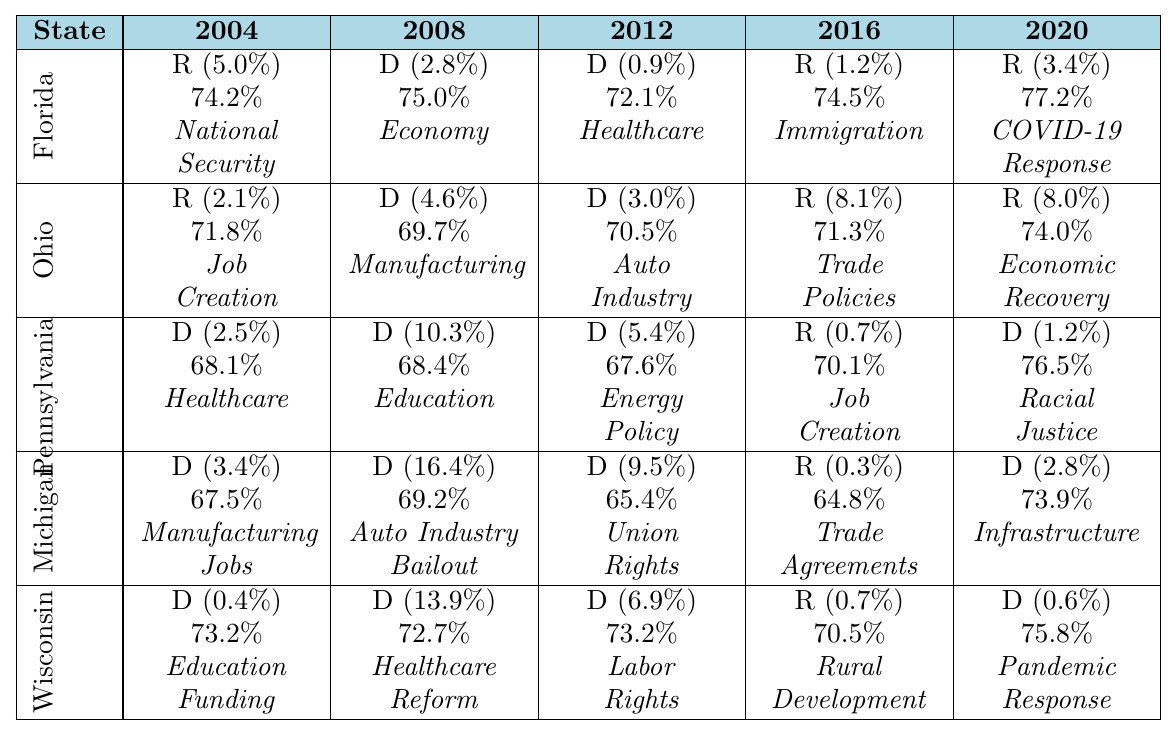What was the winner in Florida for the 2008 election? The table shows that in Florida for the 2008 election, the winner was a Democrat (D) with a margin of 2.8%.
Answer: Democrat Which state had the highest voter turnout in the 2012 election? Looking at the voter turnout for the 2012 election, Florida had a turnout of 72.1%, Ohio had 70.5%, Pennsylvania had 67.6%, Michigan had 65.4%, and Wisconsin had 73.2%. The highest voter turnout was in Wisconsin with 73.2%.
Answer: Wisconsin What was the average margin of victory for Republicans in the last three elections (2016, 2020, and 2024)? For 2016, the Republican margin in Florida was 1.2%, in Ohio it was 8.1%, in Pennsylvania it was 0.7%, in Michigan it was 0.3%, and in Wisconsin it was 0.7%. In 2020, the margins for Republicans were 3.4%, 8.0%, and none for Pennsylvania and Michigan as Democrats won. Thus, we only consider Florida, Ohio, and Wisconsin which had margins of 1.2%, 8.1%, and 0.7%, totaling 10.0%, averaging to 10.0% / 3 = 3.33%.
Answer: 3.33% Did voter turnout increase or decrease in Pennsylvania from 2012 to 2020? In Pennsylvania, the voter turnout was 67.6% in 2012 and increased to 76.5% in 2020. Since 76.5% is greater than 67.6%, it indicates a clear increase.
Answer: Increase How did the voting pattern in Michigan change from 2008 to 2016? In 2008, Democrats won with a margin of 16.4% in Michigan, while in 2016, Republicans won with a margin of only 0.3%. This shows a significant shift from Democratic to Republican dominance.
Answer: Shift to Republican Which key issue was predominant in Ohio for the 2016 election? The key issue listed for Ohio in the 2016 election was Trade Policies. This can be directly read from the respective row for the state and election.
Answer: Trade Policies Which state had a consistent Democratic majority across all five elections? Examining the table, Pennsylvania shows a Democratic majority in 2004, 2008, 2012, and 2020, only showing a Republican win in 2016. Thus, it does not hold a consistent majority. No state had a consistent majority as all had at least one Republican win.
Answer: None Which swing state showed the smallest margin of victory in 2016? Reviewing the margins for 2016, the smallest margin of victory was in Michigan, with a margin of 0.3%.
Answer: Michigan Which key issues were most common in Florida across the five elections? The key issues for Florida in the five elections were: National Security, Economy, Healthcare, Immigration, and COVID-19 Response. Among these, 'Healthcare' and 'Economy' appeared consecutively in 2008 and 2012, being common concerns for two elections.
Answer: Economy, Healthcare Which party had stronger voter turnout in the 2020 election across all swing states? In 2020, the voter turnout was as follows: Florida (Republicans 77.2%), Ohio (Republicans 74.0%), Pennsylvania (Democrats 76.5%), Michigan (Democrats 73.9%), and Wisconsin (Democrats 75.8%). Comparing the totals, Republicans had higher turnout in Florida and Ohio (combined 151.2%), while Democrats had higher in Pennsylvania, Michigan, and Wisconsin (combined 226.2%). Therefore, Democrats had stronger overall turnout.
Answer: Democrats 